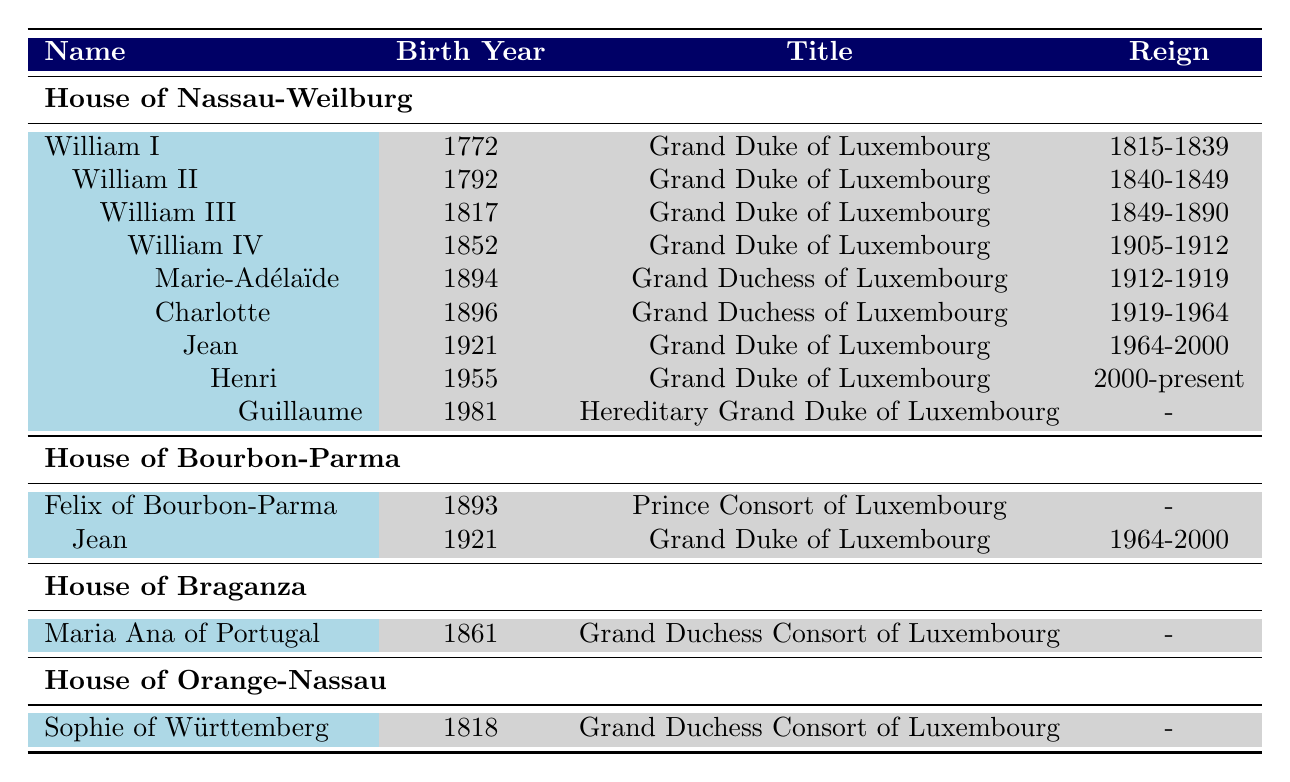What is the birth year of William III? In the table, under the House of Nassau-Weilburg, the row for William III shows his birth year as 1817.
Answer: 1817 Who was the Grand Duchess of Luxembourg that reigned after William IV? After William IV, Charlotte became the Grand Duchess of Luxembourg, as indicated in the table under her reign from 1919 to 1964.
Answer: Charlotte Which noble family does Jean belong to? In the table, Jean is listed under both the House of Nassau-Weilburg and the House of Bourbon-Parma, indicating his lineage and titles within both noble families.
Answer: House of Nassau-Weilburg and House of Bourbon-Parma What is the title of Guillaume? Guillaume is listed in the table with the title of Hereditary Grand Duke of Luxembourg.
Answer: Hereditary Grand Duke of Luxembourg How many generations are there from William I to Guillaume? Starting with William I down to Guillaume, we trace William I to William II (1 generation), William II to William III (2), William III to William IV (3), William IV to Charlotte (4), Charlotte to Jean (5), Jean to Henri (6), and Henri to Guillaume (7), making it a total of 7 generations.
Answer: 7 Did Maria Ana of Portugal have any children listed in the table? The table shows that Maria Ana of Portugal does not list any children; her entry only mentions her title and birth year.
Answer: No Which Grand Duke reigned from 1964 to 2000? The table indicates that Jean reigned as Grand Duke of Luxembourg from 1964 to 2000.
Answer: Jean Is there a Grand Duchess of Luxembourg born in 1894? Referring to the table, Marie-Adélaïde is indicated as the Grand Duchess of Luxembourg and she was born in 1894.
Answer: Yes What titles did the descendants of Charlotte hold? The descendants of Charlotte listed in the table include Jean, who was Grand Duke of Luxembourg, and Henri, who is currently Grand Duke, indicating that both held the title of Grand Duke.
Answer: Grand Duke of Luxembourg What is the relationship between Henri and Guillaume? The table shows that Henri is the father of Guillaume, indicating a direct father-son relationship between the two.
Answer: Father and son 